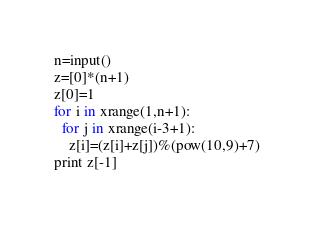Convert code to text. <code><loc_0><loc_0><loc_500><loc_500><_Python_>n=input()
z=[0]*(n+1)
z[0]=1
for i in xrange(1,n+1):
  for j in xrange(i-3+1):
    z[i]=(z[i]+z[j])%(pow(10,9)+7)
print z[-1]</code> 